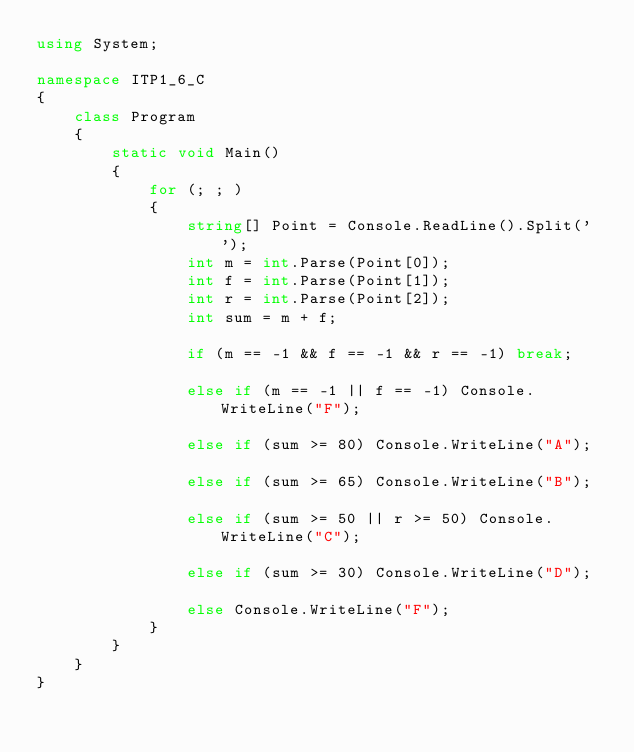Convert code to text. <code><loc_0><loc_0><loc_500><loc_500><_C#_>using System;

namespace ITP1_6_C
{
    class Program
    {
        static void Main()
        {
            for (; ; )
            {
                string[] Point = Console.ReadLine().Split(' ');
                int m = int.Parse(Point[0]);
                int f = int.Parse(Point[1]);
                int r = int.Parse(Point[2]);
                int sum = m + f;

                if (m == -1 && f == -1 && r == -1) break;

                else if (m == -1 || f == -1) Console.WriteLine("F");

                else if (sum >= 80) Console.WriteLine("A");

                else if (sum >= 65) Console.WriteLine("B");

                else if (sum >= 50 || r >= 50) Console.WriteLine("C");

                else if (sum >= 30) Console.WriteLine("D");

                else Console.WriteLine("F");
            }
        }
    }
}</code> 